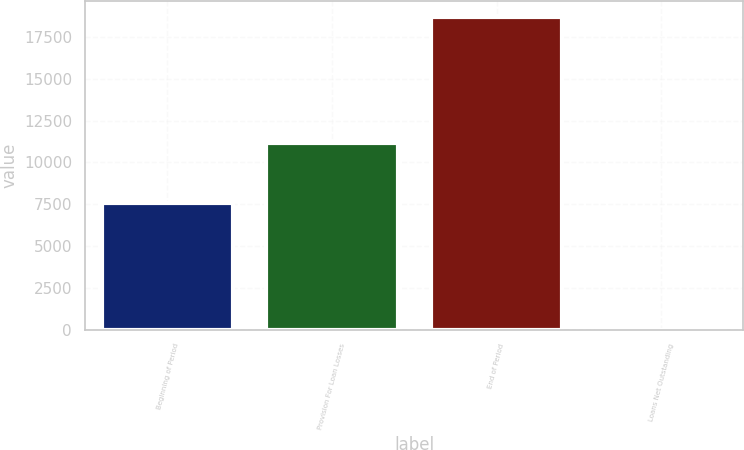Convert chart to OTSL. <chart><loc_0><loc_0><loc_500><loc_500><bar_chart><fcel>Beginning of Period<fcel>Provision For Loan Losses<fcel>End of Period<fcel>Loans Net Outstanding<nl><fcel>7593<fcel>11153<fcel>18694<fcel>0.81<nl></chart> 